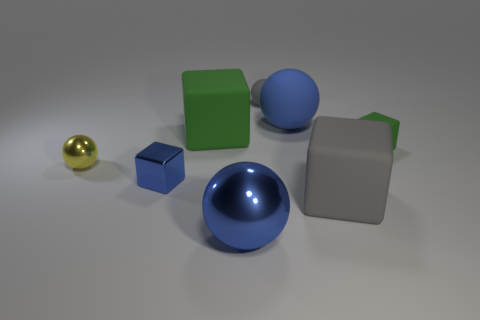How many other objects are there of the same size as the metallic cube?
Your response must be concise. 3. What number of objects are things that are behind the blue rubber sphere or blue objects that are on the right side of the tiny blue block?
Provide a short and direct response. 3. Do the big gray cube and the large ball that is in front of the metallic block have the same material?
Make the answer very short. No. How many other things are there of the same shape as the large green matte object?
Make the answer very short. 3. What is the material of the ball to the left of the big thing that is in front of the big block to the right of the blue metal sphere?
Keep it short and to the point. Metal. Are there an equal number of large green rubber objects to the left of the big green cube and gray rubber objects?
Give a very brief answer. No. Are the cube that is right of the big gray thing and the green object on the left side of the gray cube made of the same material?
Provide a short and direct response. Yes. Is the shape of the gray object behind the tiny yellow object the same as the blue metal thing that is to the right of the big green rubber block?
Your answer should be compact. Yes. Is the number of tiny gray rubber balls left of the tiny gray matte thing less than the number of tiny objects?
Your response must be concise. Yes. How many rubber balls are the same color as the small metallic block?
Your answer should be compact. 1. 